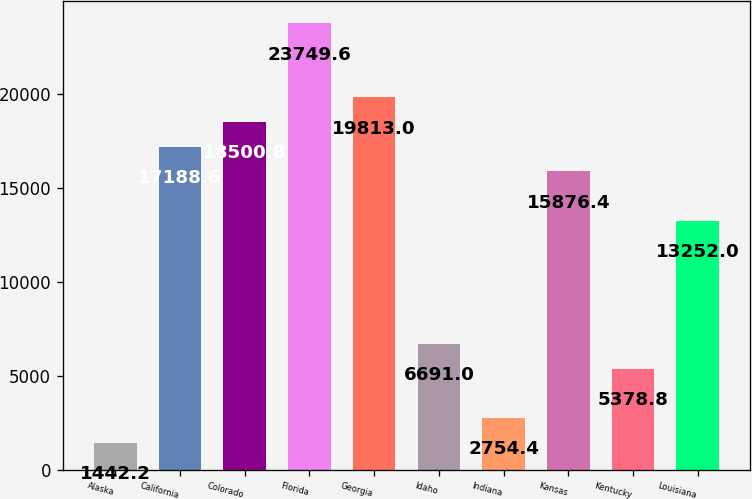Convert chart. <chart><loc_0><loc_0><loc_500><loc_500><bar_chart><fcel>Alaska<fcel>California<fcel>Colorado<fcel>Florida<fcel>Georgia<fcel>Idaho<fcel>Indiana<fcel>Kansas<fcel>Kentucky<fcel>Louisiana<nl><fcel>1442.2<fcel>17188.6<fcel>18500.8<fcel>23749.6<fcel>19813<fcel>6691<fcel>2754.4<fcel>15876.4<fcel>5378.8<fcel>13252<nl></chart> 